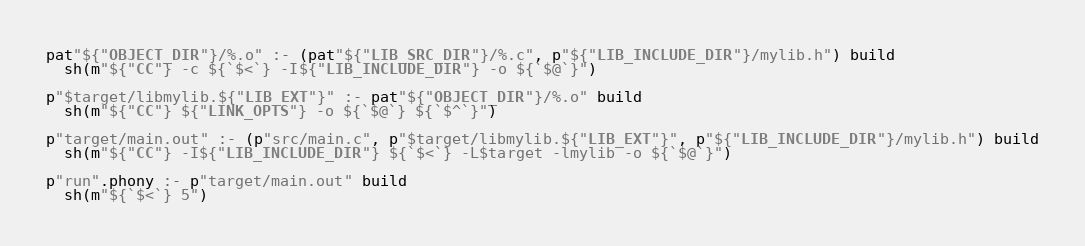Convert code to text. <code><loc_0><loc_0><loc_500><loc_500><_Scala_>
pat"${"OBJECT_DIR"}/%.o" :- (pat"${"LIB_SRC_DIR"}/%.c", p"${"LIB_INCLUDE_DIR"}/mylib.h") build
  sh(m"${"CC"} -c ${`$<`} -I${"LIB_INCLUDE_DIR"} -o ${`$@`}")

p"$target/libmylib.${"LIB_EXT"}" :- pat"${"OBJECT_DIR"}/%.o" build
  sh(m"${"CC"} ${"LINK_OPTS"} -o ${`$@`} ${`$^`}")

p"target/main.out" :- (p"src/main.c", p"$target/libmylib.${"LIB_EXT"}", p"${"LIB_INCLUDE_DIR"}/mylib.h") build
  sh(m"${"CC"} -I${"LIB_INCLUDE_DIR"} ${`$<`} -L$target -lmylib -o ${`$@`}")

p"run".phony :- p"target/main.out" build
  sh(m"${`$<`} 5")
</code> 